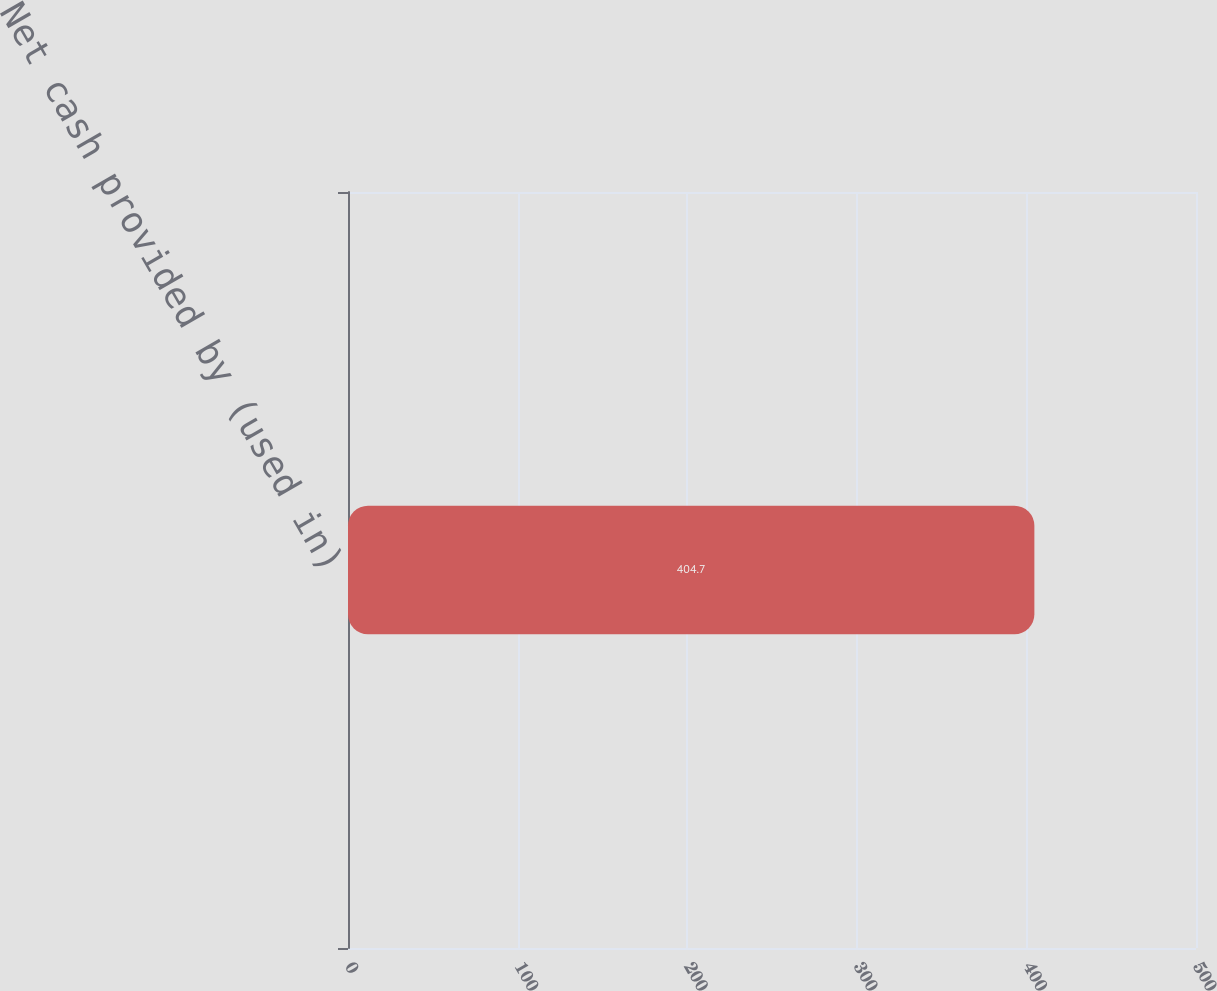Convert chart. <chart><loc_0><loc_0><loc_500><loc_500><bar_chart><fcel>Net cash provided by (used in)<nl><fcel>404.7<nl></chart> 